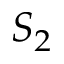Convert formula to latex. <formula><loc_0><loc_0><loc_500><loc_500>S _ { 2 }</formula> 